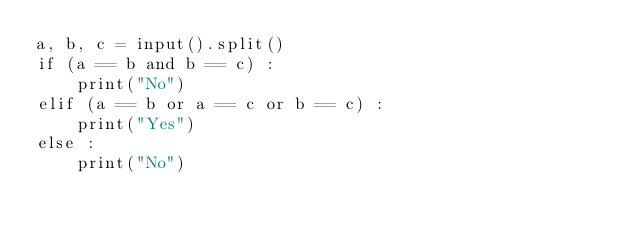<code> <loc_0><loc_0><loc_500><loc_500><_Python_>a, b, c = input().split()
if (a == b and b == c) :
    print("No")
elif (a == b or a == c or b == c) :
    print("Yes")
else :
    print("No")</code> 